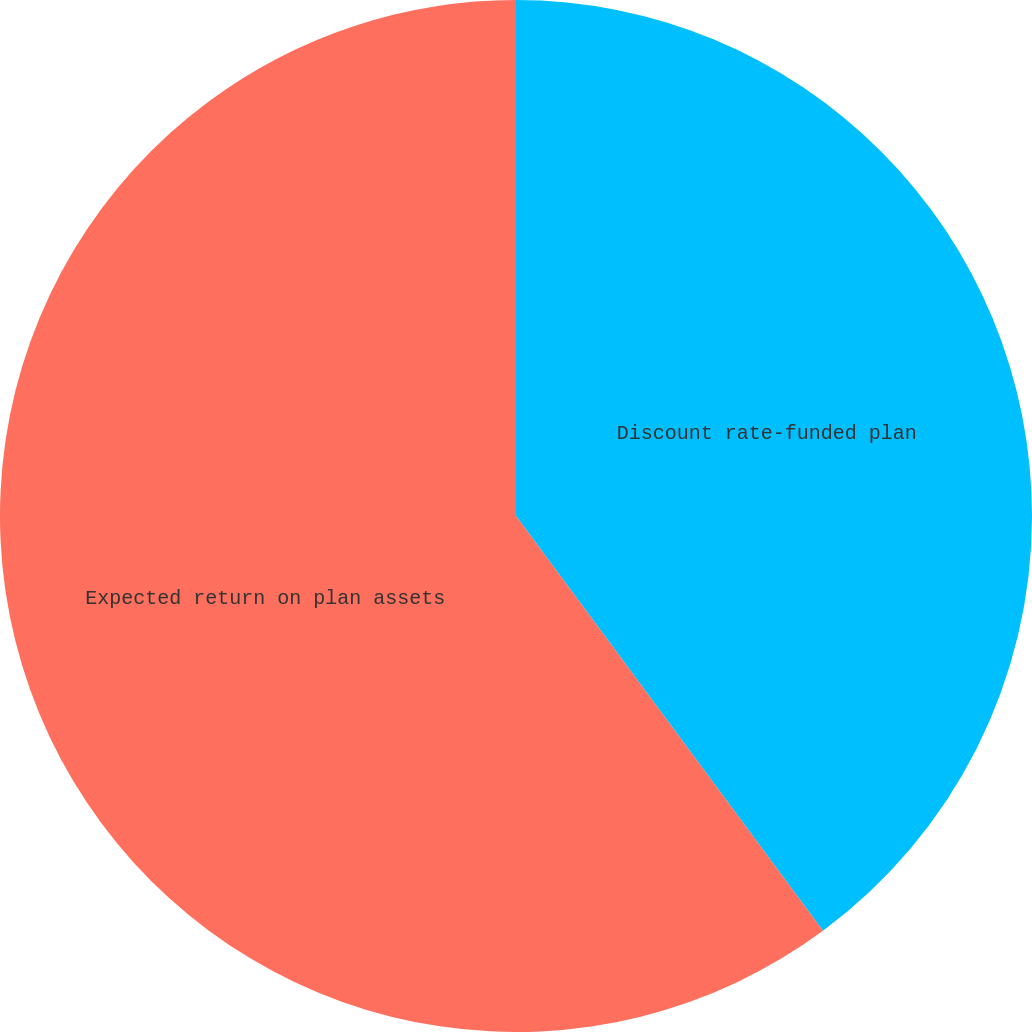Convert chart to OTSL. <chart><loc_0><loc_0><loc_500><loc_500><pie_chart><fcel>Discount rate-funded plan<fcel>Expected return on plan assets<nl><fcel>39.86%<fcel>60.14%<nl></chart> 